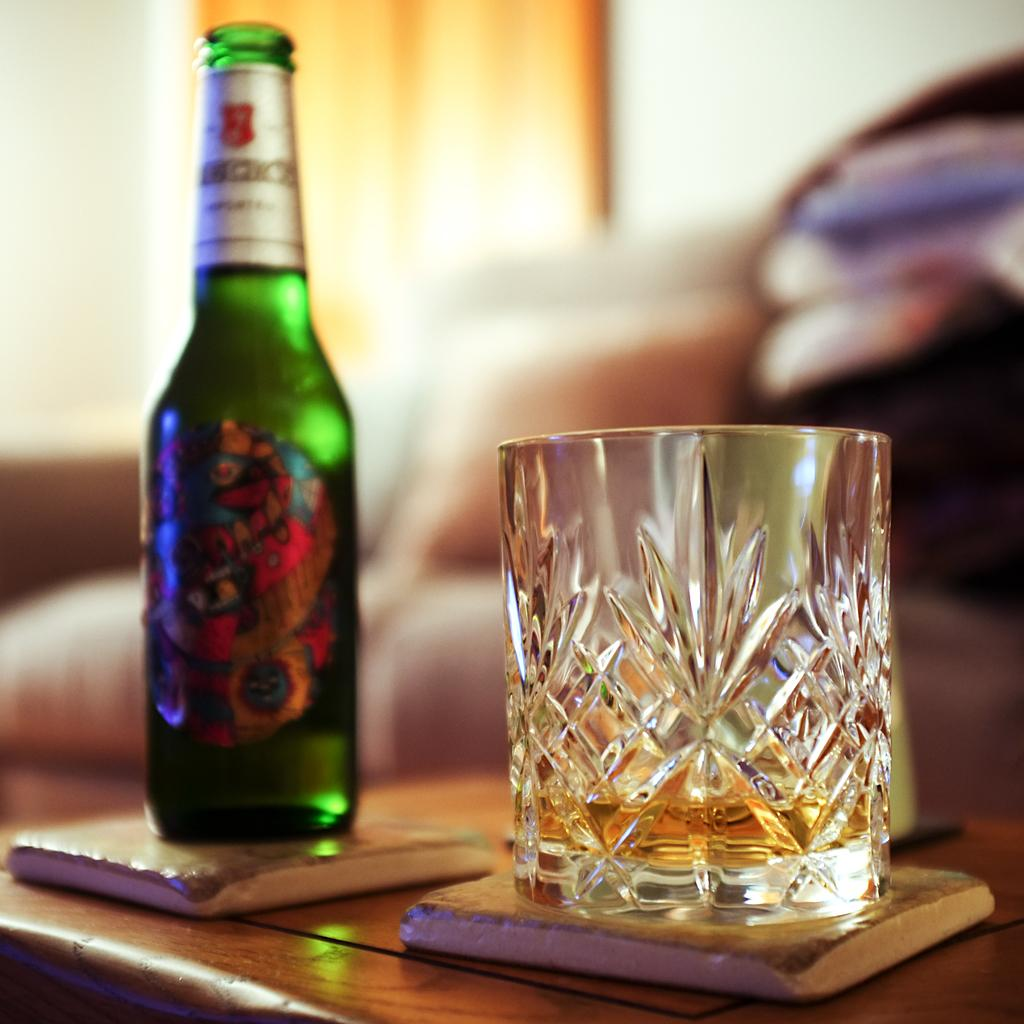What is on the table in the image? There is a bottle and a glass of drink on the table. What type of bun is being used to hold the drink in the image? There is no bun present in the image; it features a bottle and a glass of drink on the table. 